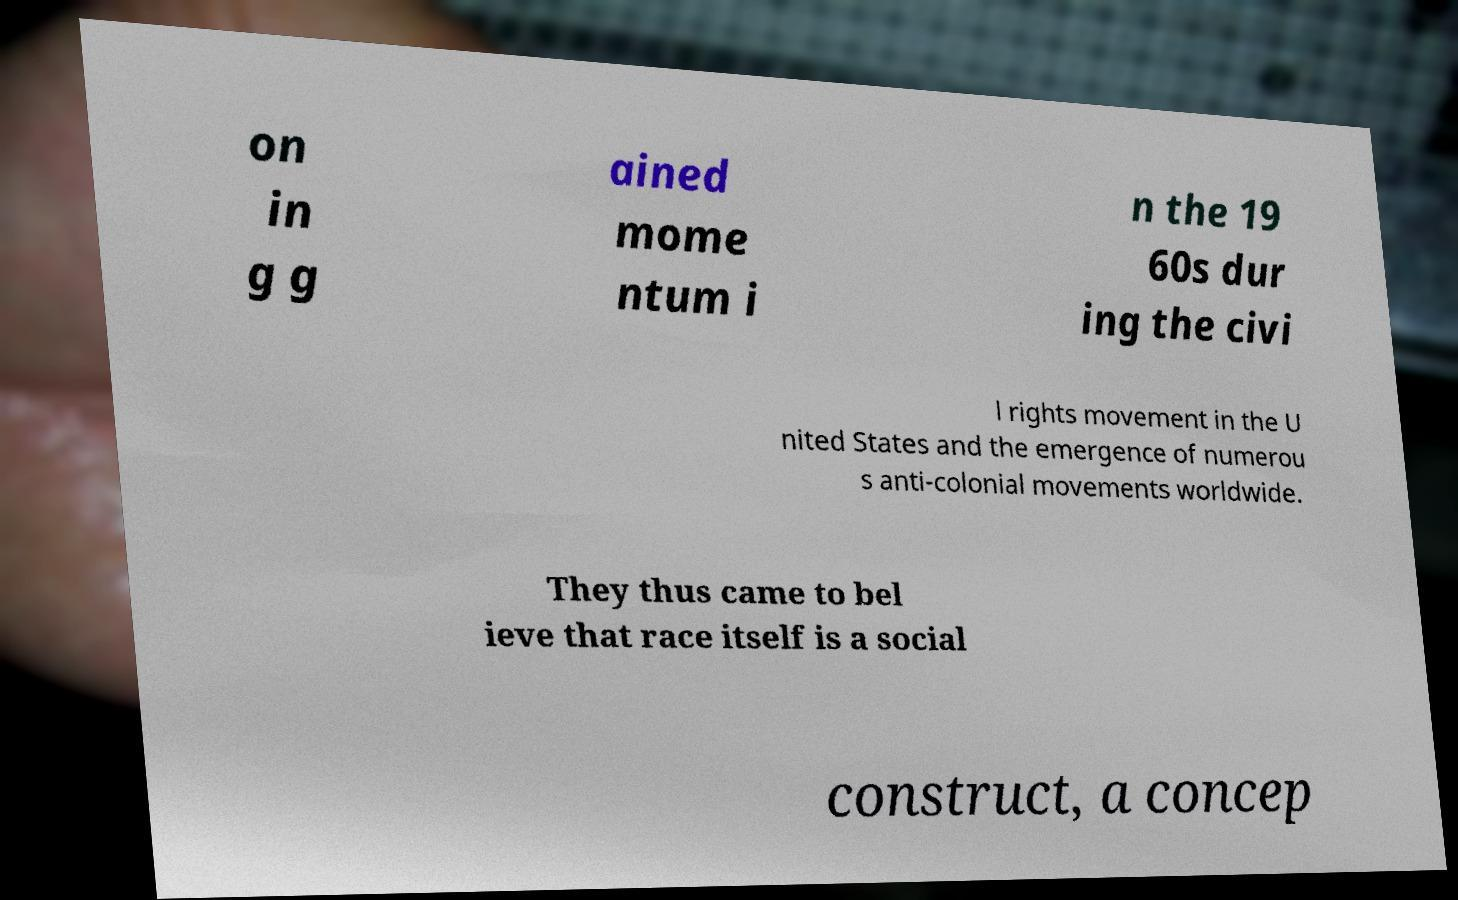What messages or text are displayed in this image? I need them in a readable, typed format. on in g g ained mome ntum i n the 19 60s dur ing the civi l rights movement in the U nited States and the emergence of numerou s anti-colonial movements worldwide. They thus came to bel ieve that race itself is a social construct, a concep 